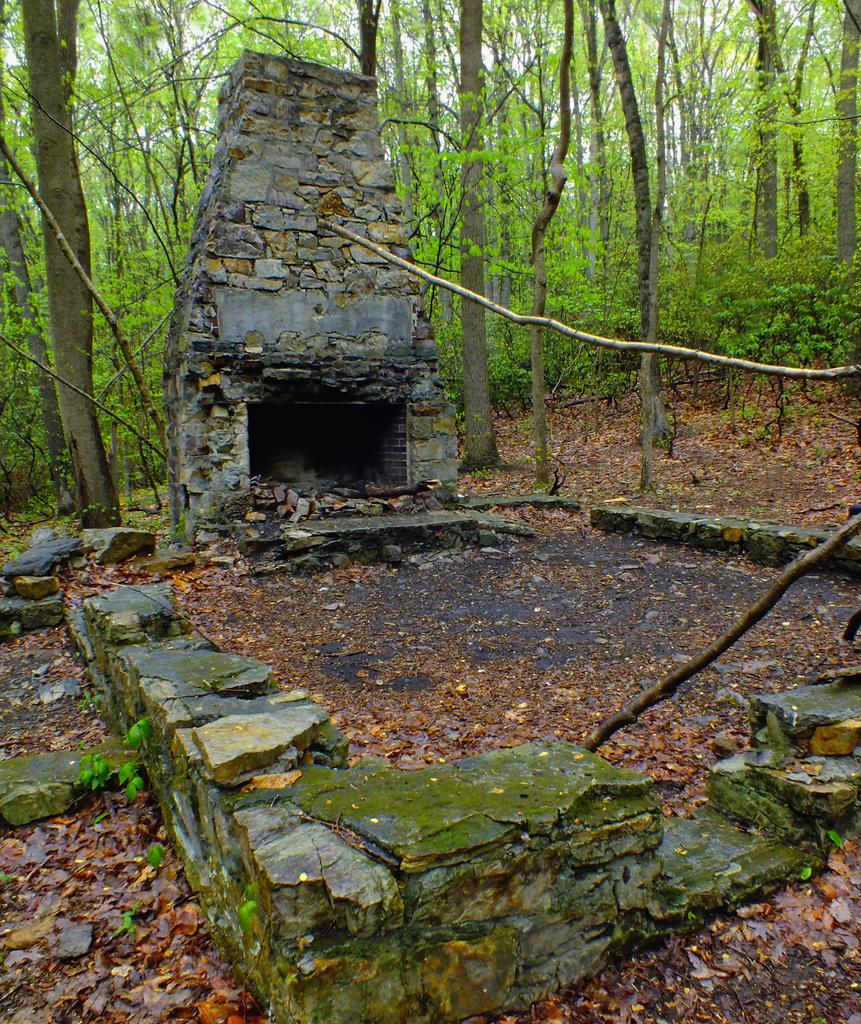What is the main subject of the image? There is a monument in the image. What can be seen in the background of the image? There are trees in the background of the image. What type of control panel can be seen on the monument in the image? There is no control panel visible on the monument in the image. Is there a hospital located near the monument in the image? There is no information about a hospital in the image; it only features a monument and trees in the background. 